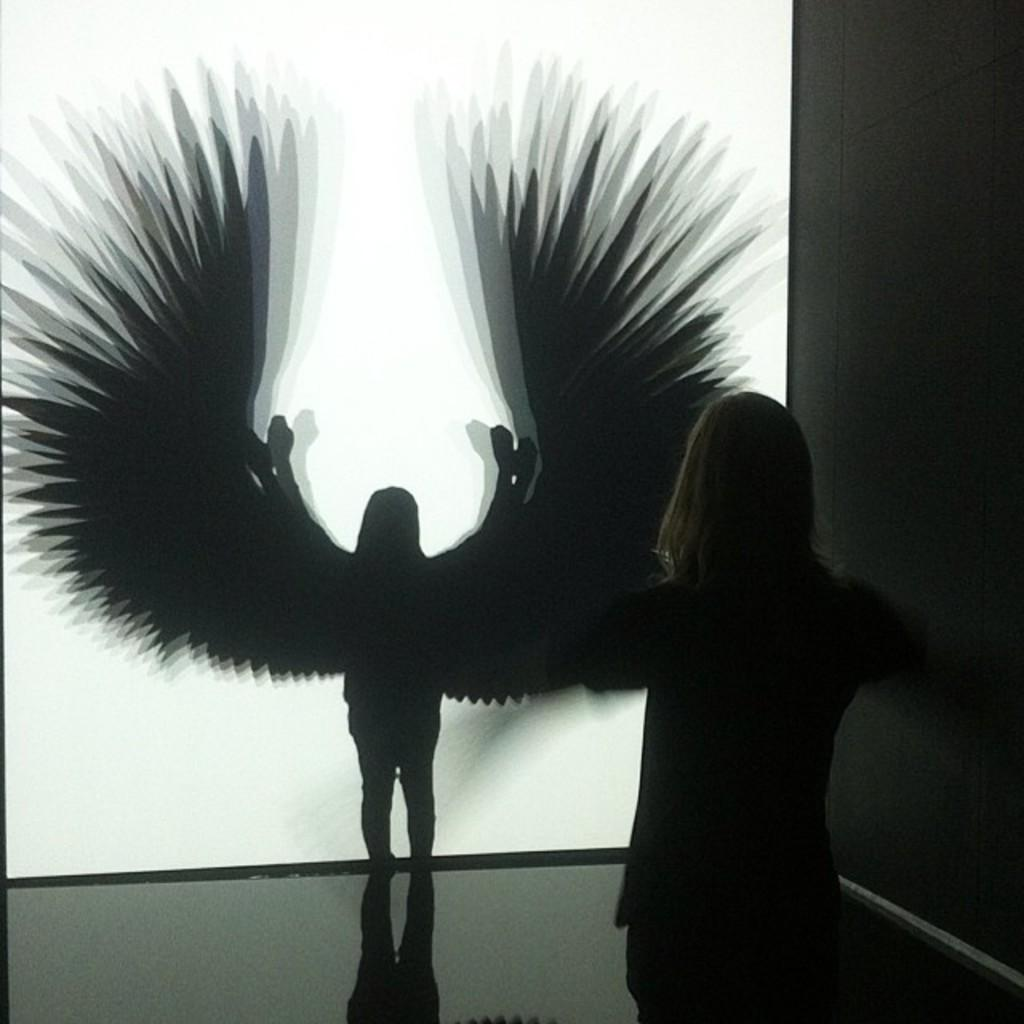Who is the main subject in the image? There is a girl in the image. What is the girl doing in the image? The girl is standing on the floor. What can be seen on the wall in the image? There is a painting of an angel in the image. What type of yarn is the girl using to create a beetle in the image? There is no yarn or beetle present in the image. The girl is simply standing on the floor, and there is a painting of an angel on the wall. 